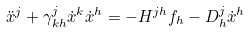<formula> <loc_0><loc_0><loc_500><loc_500>\ddot { x } ^ { j } + \gamma _ { k h } ^ { j } \dot { x } ^ { k } \dot { x } ^ { h } = - H ^ { j h } f _ { h } - D _ { h } ^ { j } \dot { x } ^ { h }</formula> 